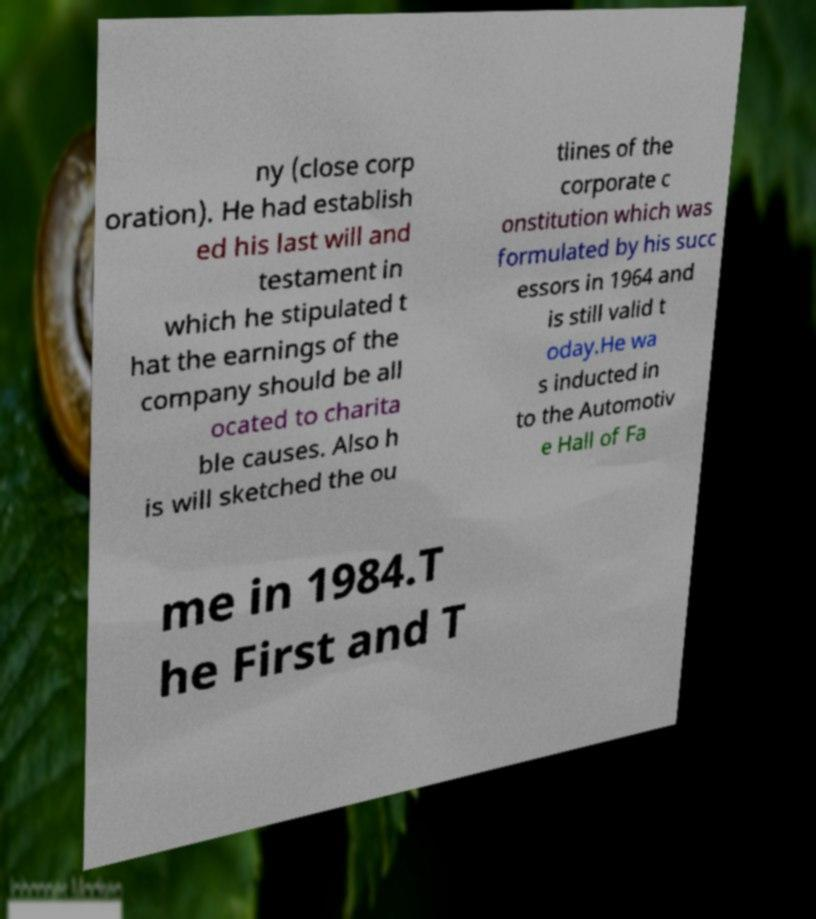Can you read and provide the text displayed in the image?This photo seems to have some interesting text. Can you extract and type it out for me? ny (close corp oration). He had establish ed his last will and testament in which he stipulated t hat the earnings of the company should be all ocated to charita ble causes. Also h is will sketched the ou tlines of the corporate c onstitution which was formulated by his succ essors in 1964 and is still valid t oday.He wa s inducted in to the Automotiv e Hall of Fa me in 1984.T he First and T 